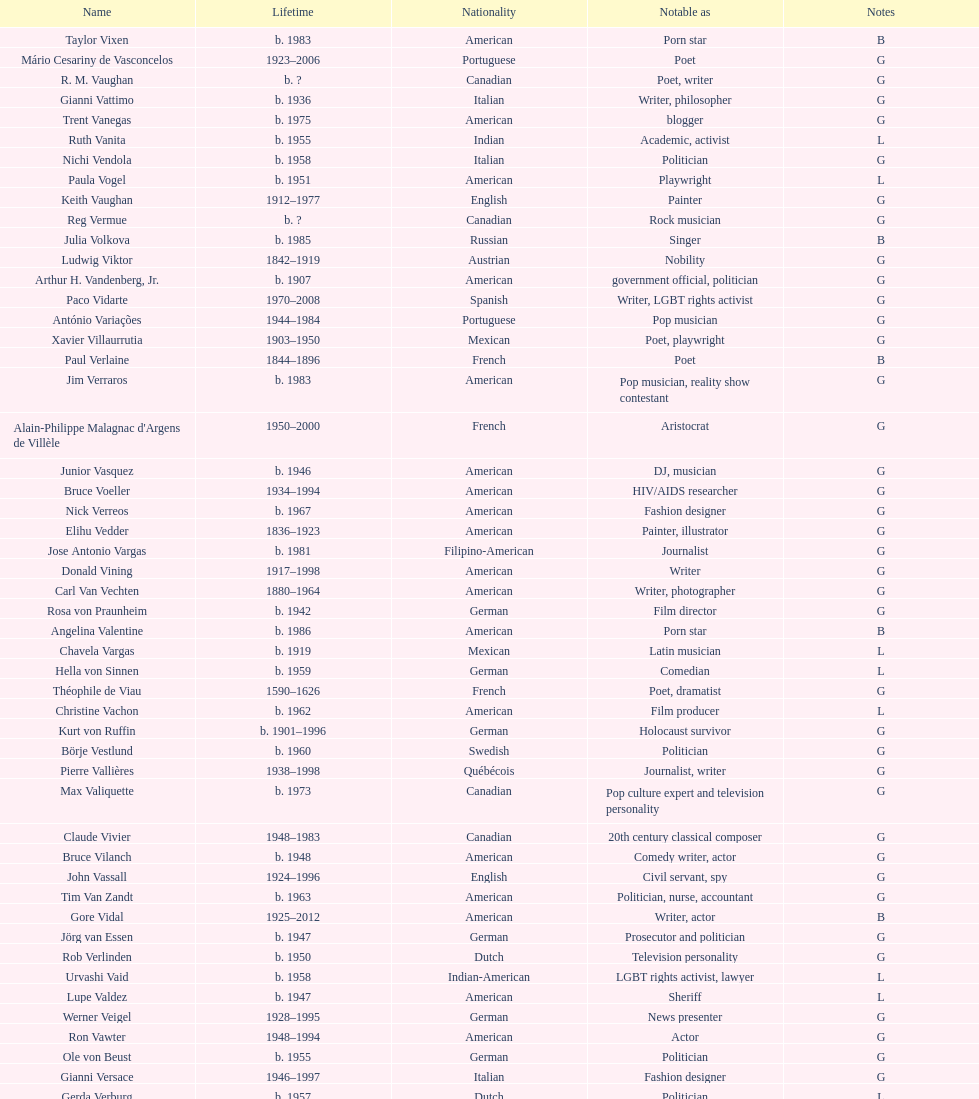Which nationality has the most people associated with it? American. 